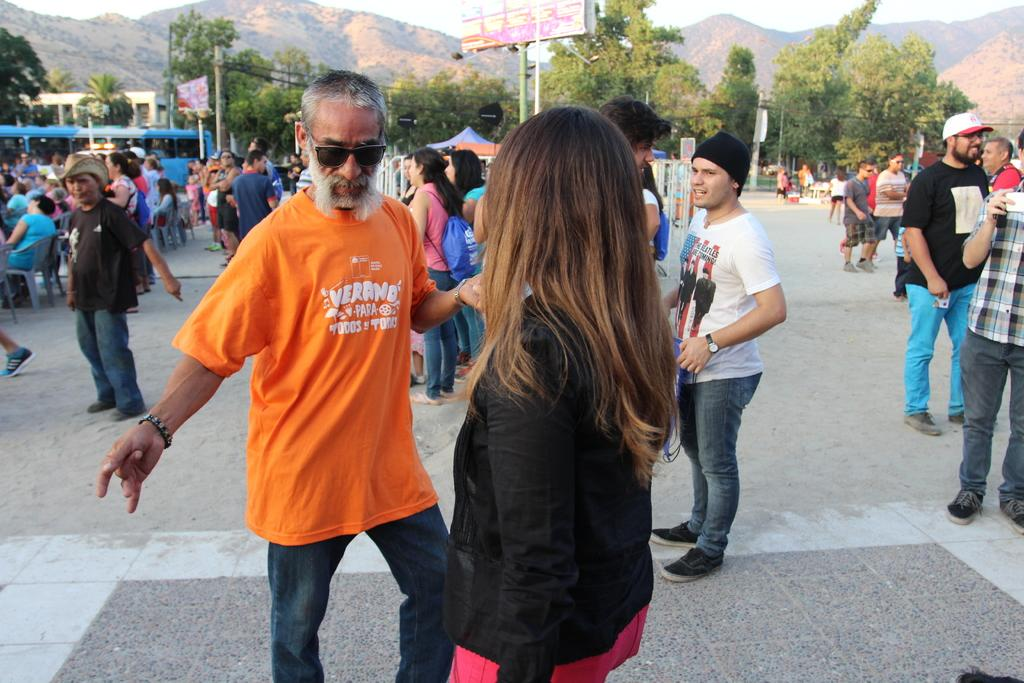What is the main subject of the image? The main subject of the image is a crowd of people. What type of protective gear are some people wearing? Some people are wearing goggles in the image. What type of headwear can be seen on some people? Some people are wearing caps in the image. What are some people carrying in the image? Some people are wearing bags in the image. What are some people doing in the image? Some people are sitting on chairs in the image. What can be seen in the background of the image? There are trees, hills, and sky visible in the background of the image. What structures are present in the image? There are poles in the image. What type of quill is being used by the people in the image? There is no quill present in the image; it is a crowd of people in an outdoor setting. How does the amusement park support the people in the image? The image does not depict an amusement park, so there is no support provided by an amusement park. 